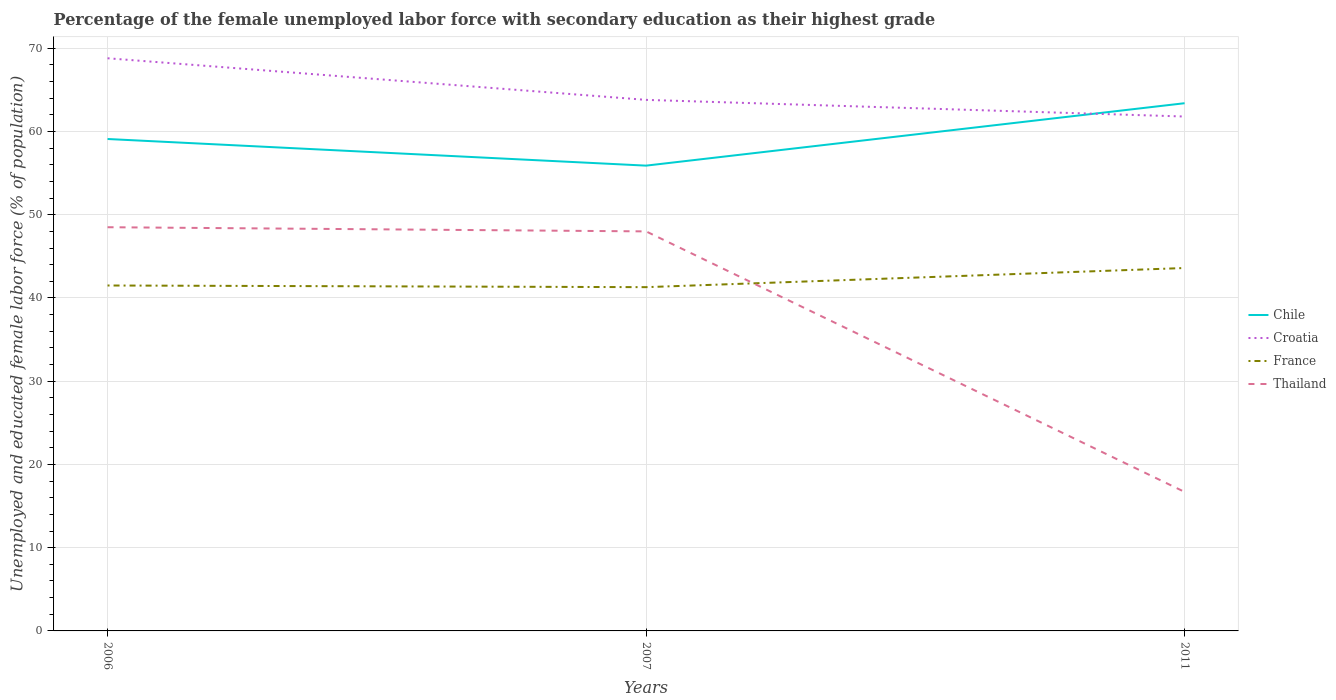How many different coloured lines are there?
Make the answer very short. 4. Across all years, what is the maximum percentage of the unemployed female labor force with secondary education in Thailand?
Offer a terse response. 16.7. What is the total percentage of the unemployed female labor force with secondary education in Thailand in the graph?
Give a very brief answer. 31.3. What is the difference between the highest and the second highest percentage of the unemployed female labor force with secondary education in Croatia?
Provide a succinct answer. 7. What is the difference between the highest and the lowest percentage of the unemployed female labor force with secondary education in Thailand?
Your answer should be compact. 2. Is the percentage of the unemployed female labor force with secondary education in Croatia strictly greater than the percentage of the unemployed female labor force with secondary education in Chile over the years?
Offer a terse response. No. What is the difference between two consecutive major ticks on the Y-axis?
Offer a very short reply. 10. Where does the legend appear in the graph?
Give a very brief answer. Center right. How many legend labels are there?
Your response must be concise. 4. How are the legend labels stacked?
Your response must be concise. Vertical. What is the title of the graph?
Your response must be concise. Percentage of the female unemployed labor force with secondary education as their highest grade. Does "Middle East & North Africa (developing only)" appear as one of the legend labels in the graph?
Offer a very short reply. No. What is the label or title of the X-axis?
Provide a succinct answer. Years. What is the label or title of the Y-axis?
Provide a succinct answer. Unemployed and educated female labor force (% of population). What is the Unemployed and educated female labor force (% of population) in Chile in 2006?
Provide a succinct answer. 59.1. What is the Unemployed and educated female labor force (% of population) in Croatia in 2006?
Your answer should be compact. 68.8. What is the Unemployed and educated female labor force (% of population) in France in 2006?
Keep it short and to the point. 41.5. What is the Unemployed and educated female labor force (% of population) of Thailand in 2006?
Make the answer very short. 48.5. What is the Unemployed and educated female labor force (% of population) in Chile in 2007?
Your answer should be compact. 55.9. What is the Unemployed and educated female labor force (% of population) in Croatia in 2007?
Provide a short and direct response. 63.8. What is the Unemployed and educated female labor force (% of population) of France in 2007?
Your response must be concise. 41.3. What is the Unemployed and educated female labor force (% of population) of Chile in 2011?
Offer a terse response. 63.4. What is the Unemployed and educated female labor force (% of population) of Croatia in 2011?
Your response must be concise. 61.8. What is the Unemployed and educated female labor force (% of population) of France in 2011?
Ensure brevity in your answer.  43.6. What is the Unemployed and educated female labor force (% of population) of Thailand in 2011?
Ensure brevity in your answer.  16.7. Across all years, what is the maximum Unemployed and educated female labor force (% of population) of Chile?
Give a very brief answer. 63.4. Across all years, what is the maximum Unemployed and educated female labor force (% of population) in Croatia?
Your answer should be very brief. 68.8. Across all years, what is the maximum Unemployed and educated female labor force (% of population) in France?
Your answer should be very brief. 43.6. Across all years, what is the maximum Unemployed and educated female labor force (% of population) in Thailand?
Your response must be concise. 48.5. Across all years, what is the minimum Unemployed and educated female labor force (% of population) of Chile?
Your answer should be compact. 55.9. Across all years, what is the minimum Unemployed and educated female labor force (% of population) of Croatia?
Keep it short and to the point. 61.8. Across all years, what is the minimum Unemployed and educated female labor force (% of population) in France?
Give a very brief answer. 41.3. Across all years, what is the minimum Unemployed and educated female labor force (% of population) of Thailand?
Keep it short and to the point. 16.7. What is the total Unemployed and educated female labor force (% of population) in Chile in the graph?
Give a very brief answer. 178.4. What is the total Unemployed and educated female labor force (% of population) in Croatia in the graph?
Provide a succinct answer. 194.4. What is the total Unemployed and educated female labor force (% of population) in France in the graph?
Give a very brief answer. 126.4. What is the total Unemployed and educated female labor force (% of population) in Thailand in the graph?
Offer a very short reply. 113.2. What is the difference between the Unemployed and educated female labor force (% of population) of France in 2006 and that in 2007?
Provide a short and direct response. 0.2. What is the difference between the Unemployed and educated female labor force (% of population) in Chile in 2006 and that in 2011?
Offer a very short reply. -4.3. What is the difference between the Unemployed and educated female labor force (% of population) of France in 2006 and that in 2011?
Make the answer very short. -2.1. What is the difference between the Unemployed and educated female labor force (% of population) of Thailand in 2006 and that in 2011?
Your answer should be very brief. 31.8. What is the difference between the Unemployed and educated female labor force (% of population) in Chile in 2007 and that in 2011?
Make the answer very short. -7.5. What is the difference between the Unemployed and educated female labor force (% of population) of France in 2007 and that in 2011?
Keep it short and to the point. -2.3. What is the difference between the Unemployed and educated female labor force (% of population) of Thailand in 2007 and that in 2011?
Your answer should be very brief. 31.3. What is the difference between the Unemployed and educated female labor force (% of population) in Croatia in 2006 and the Unemployed and educated female labor force (% of population) in France in 2007?
Your answer should be very brief. 27.5. What is the difference between the Unemployed and educated female labor force (% of population) in Croatia in 2006 and the Unemployed and educated female labor force (% of population) in Thailand in 2007?
Keep it short and to the point. 20.8. What is the difference between the Unemployed and educated female labor force (% of population) in Chile in 2006 and the Unemployed and educated female labor force (% of population) in Croatia in 2011?
Ensure brevity in your answer.  -2.7. What is the difference between the Unemployed and educated female labor force (% of population) of Chile in 2006 and the Unemployed and educated female labor force (% of population) of France in 2011?
Give a very brief answer. 15.5. What is the difference between the Unemployed and educated female labor force (% of population) in Chile in 2006 and the Unemployed and educated female labor force (% of population) in Thailand in 2011?
Give a very brief answer. 42.4. What is the difference between the Unemployed and educated female labor force (% of population) in Croatia in 2006 and the Unemployed and educated female labor force (% of population) in France in 2011?
Offer a terse response. 25.2. What is the difference between the Unemployed and educated female labor force (% of population) of Croatia in 2006 and the Unemployed and educated female labor force (% of population) of Thailand in 2011?
Offer a very short reply. 52.1. What is the difference between the Unemployed and educated female labor force (% of population) in France in 2006 and the Unemployed and educated female labor force (% of population) in Thailand in 2011?
Provide a short and direct response. 24.8. What is the difference between the Unemployed and educated female labor force (% of population) of Chile in 2007 and the Unemployed and educated female labor force (% of population) of Thailand in 2011?
Ensure brevity in your answer.  39.2. What is the difference between the Unemployed and educated female labor force (% of population) of Croatia in 2007 and the Unemployed and educated female labor force (% of population) of France in 2011?
Offer a terse response. 20.2. What is the difference between the Unemployed and educated female labor force (% of population) in Croatia in 2007 and the Unemployed and educated female labor force (% of population) in Thailand in 2011?
Your answer should be compact. 47.1. What is the difference between the Unemployed and educated female labor force (% of population) in France in 2007 and the Unemployed and educated female labor force (% of population) in Thailand in 2011?
Ensure brevity in your answer.  24.6. What is the average Unemployed and educated female labor force (% of population) in Chile per year?
Make the answer very short. 59.47. What is the average Unemployed and educated female labor force (% of population) in Croatia per year?
Your answer should be compact. 64.8. What is the average Unemployed and educated female labor force (% of population) of France per year?
Offer a terse response. 42.13. What is the average Unemployed and educated female labor force (% of population) in Thailand per year?
Your response must be concise. 37.73. In the year 2006, what is the difference between the Unemployed and educated female labor force (% of population) in Croatia and Unemployed and educated female labor force (% of population) in France?
Your answer should be compact. 27.3. In the year 2006, what is the difference between the Unemployed and educated female labor force (% of population) of Croatia and Unemployed and educated female labor force (% of population) of Thailand?
Provide a short and direct response. 20.3. In the year 2006, what is the difference between the Unemployed and educated female labor force (% of population) of France and Unemployed and educated female labor force (% of population) of Thailand?
Give a very brief answer. -7. In the year 2007, what is the difference between the Unemployed and educated female labor force (% of population) in Chile and Unemployed and educated female labor force (% of population) in Croatia?
Your answer should be very brief. -7.9. In the year 2007, what is the difference between the Unemployed and educated female labor force (% of population) of Chile and Unemployed and educated female labor force (% of population) of France?
Offer a very short reply. 14.6. In the year 2007, what is the difference between the Unemployed and educated female labor force (% of population) in Chile and Unemployed and educated female labor force (% of population) in Thailand?
Give a very brief answer. 7.9. In the year 2007, what is the difference between the Unemployed and educated female labor force (% of population) of Croatia and Unemployed and educated female labor force (% of population) of France?
Give a very brief answer. 22.5. In the year 2007, what is the difference between the Unemployed and educated female labor force (% of population) in Croatia and Unemployed and educated female labor force (% of population) in Thailand?
Your answer should be very brief. 15.8. In the year 2011, what is the difference between the Unemployed and educated female labor force (% of population) of Chile and Unemployed and educated female labor force (% of population) of Croatia?
Offer a terse response. 1.6. In the year 2011, what is the difference between the Unemployed and educated female labor force (% of population) of Chile and Unemployed and educated female labor force (% of population) of France?
Keep it short and to the point. 19.8. In the year 2011, what is the difference between the Unemployed and educated female labor force (% of population) in Chile and Unemployed and educated female labor force (% of population) in Thailand?
Make the answer very short. 46.7. In the year 2011, what is the difference between the Unemployed and educated female labor force (% of population) in Croatia and Unemployed and educated female labor force (% of population) in Thailand?
Provide a short and direct response. 45.1. In the year 2011, what is the difference between the Unemployed and educated female labor force (% of population) of France and Unemployed and educated female labor force (% of population) of Thailand?
Keep it short and to the point. 26.9. What is the ratio of the Unemployed and educated female labor force (% of population) in Chile in 2006 to that in 2007?
Your response must be concise. 1.06. What is the ratio of the Unemployed and educated female labor force (% of population) of Croatia in 2006 to that in 2007?
Your answer should be compact. 1.08. What is the ratio of the Unemployed and educated female labor force (% of population) in France in 2006 to that in 2007?
Your response must be concise. 1. What is the ratio of the Unemployed and educated female labor force (% of population) in Thailand in 2006 to that in 2007?
Offer a terse response. 1.01. What is the ratio of the Unemployed and educated female labor force (% of population) in Chile in 2006 to that in 2011?
Offer a very short reply. 0.93. What is the ratio of the Unemployed and educated female labor force (% of population) of Croatia in 2006 to that in 2011?
Your answer should be very brief. 1.11. What is the ratio of the Unemployed and educated female labor force (% of population) of France in 2006 to that in 2011?
Make the answer very short. 0.95. What is the ratio of the Unemployed and educated female labor force (% of population) of Thailand in 2006 to that in 2011?
Ensure brevity in your answer.  2.9. What is the ratio of the Unemployed and educated female labor force (% of population) in Chile in 2007 to that in 2011?
Provide a succinct answer. 0.88. What is the ratio of the Unemployed and educated female labor force (% of population) of Croatia in 2007 to that in 2011?
Your answer should be compact. 1.03. What is the ratio of the Unemployed and educated female labor force (% of population) of France in 2007 to that in 2011?
Ensure brevity in your answer.  0.95. What is the ratio of the Unemployed and educated female labor force (% of population) in Thailand in 2007 to that in 2011?
Ensure brevity in your answer.  2.87. What is the difference between the highest and the second highest Unemployed and educated female labor force (% of population) of Chile?
Give a very brief answer. 4.3. What is the difference between the highest and the second highest Unemployed and educated female labor force (% of population) in Thailand?
Keep it short and to the point. 0.5. What is the difference between the highest and the lowest Unemployed and educated female labor force (% of population) of Chile?
Give a very brief answer. 7.5. What is the difference between the highest and the lowest Unemployed and educated female labor force (% of population) in Thailand?
Your answer should be compact. 31.8. 